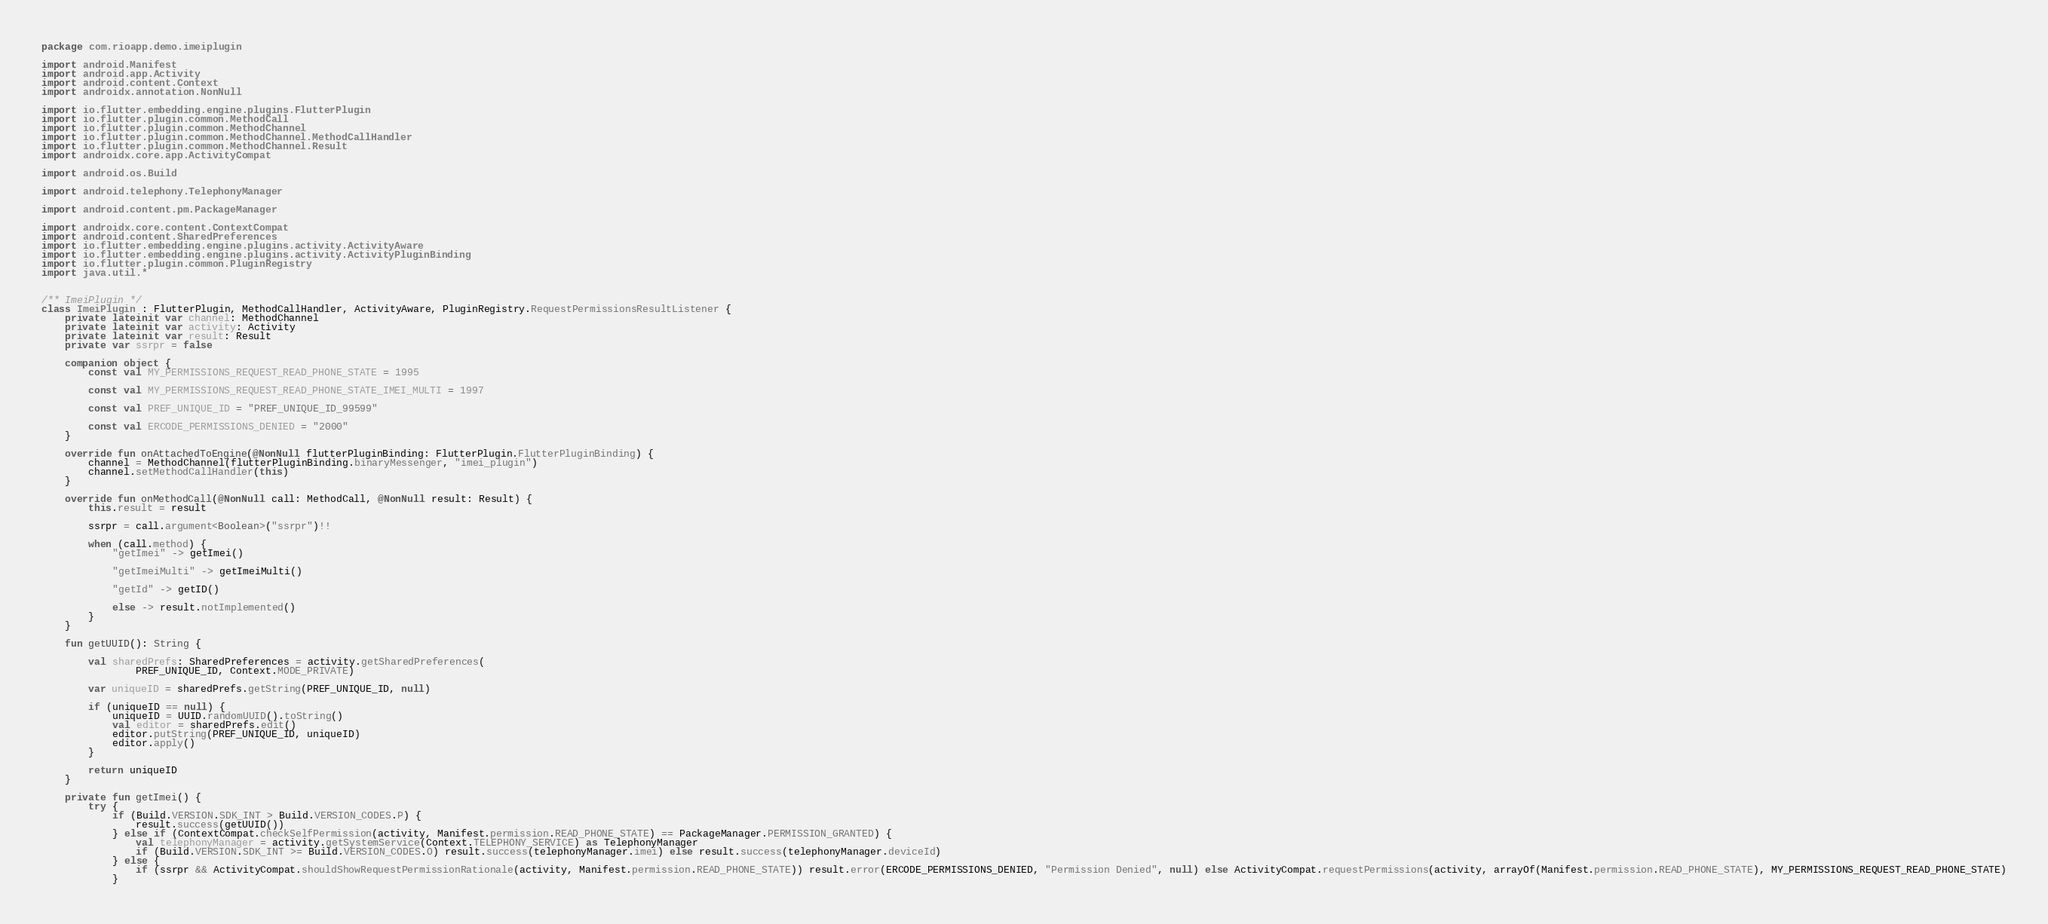Convert code to text. <code><loc_0><loc_0><loc_500><loc_500><_Kotlin_>package com.rioapp.demo.imeiplugin

import android.Manifest
import android.app.Activity
import android.content.Context
import androidx.annotation.NonNull

import io.flutter.embedding.engine.plugins.FlutterPlugin
import io.flutter.plugin.common.MethodCall
import io.flutter.plugin.common.MethodChannel
import io.flutter.plugin.common.MethodChannel.MethodCallHandler
import io.flutter.plugin.common.MethodChannel.Result
import androidx.core.app.ActivityCompat

import android.os.Build

import android.telephony.TelephonyManager

import android.content.pm.PackageManager

import androidx.core.content.ContextCompat
import android.content.SharedPreferences
import io.flutter.embedding.engine.plugins.activity.ActivityAware
import io.flutter.embedding.engine.plugins.activity.ActivityPluginBinding
import io.flutter.plugin.common.PluginRegistry
import java.util.*


/** ImeiPlugin */
class ImeiPlugin : FlutterPlugin, MethodCallHandler, ActivityAware, PluginRegistry.RequestPermissionsResultListener {
    private lateinit var channel: MethodChannel
    private lateinit var activity: Activity
    private lateinit var result: Result
    private var ssrpr = false

    companion object {
        const val MY_PERMISSIONS_REQUEST_READ_PHONE_STATE = 1995

        const val MY_PERMISSIONS_REQUEST_READ_PHONE_STATE_IMEI_MULTI = 1997

        const val PREF_UNIQUE_ID = "PREF_UNIQUE_ID_99599"

        const val ERCODE_PERMISSIONS_DENIED = "2000"
    }

    override fun onAttachedToEngine(@NonNull flutterPluginBinding: FlutterPlugin.FlutterPluginBinding) {
        channel = MethodChannel(flutterPluginBinding.binaryMessenger, "imei_plugin")
        channel.setMethodCallHandler(this)
    }

    override fun onMethodCall(@NonNull call: MethodCall, @NonNull result: Result) {
        this.result = result

        ssrpr = call.argument<Boolean>("ssrpr")!!

        when (call.method) {
            "getImei" -> getImei()

            "getImeiMulti" -> getImeiMulti()

            "getId" -> getID()

            else -> result.notImplemented()
        }
    }

    fun getUUID(): String {

        val sharedPrefs: SharedPreferences = activity.getSharedPreferences(
                PREF_UNIQUE_ID, Context.MODE_PRIVATE)

        var uniqueID = sharedPrefs.getString(PREF_UNIQUE_ID, null)

        if (uniqueID == null) {
            uniqueID = UUID.randomUUID().toString()
            val editor = sharedPrefs.edit()
            editor.putString(PREF_UNIQUE_ID, uniqueID)
            editor.apply()
        }

        return uniqueID
    }

    private fun getImei() {
        try {
            if (Build.VERSION.SDK_INT > Build.VERSION_CODES.P) {
                result.success(getUUID())
            } else if (ContextCompat.checkSelfPermission(activity, Manifest.permission.READ_PHONE_STATE) == PackageManager.PERMISSION_GRANTED) {
                val telephonyManager = activity.getSystemService(Context.TELEPHONY_SERVICE) as TelephonyManager
                if (Build.VERSION.SDK_INT >= Build.VERSION_CODES.O) result.success(telephonyManager.imei) else result.success(telephonyManager.deviceId)
            } else {
                if (ssrpr && ActivityCompat.shouldShowRequestPermissionRationale(activity, Manifest.permission.READ_PHONE_STATE)) result.error(ERCODE_PERMISSIONS_DENIED, "Permission Denied", null) else ActivityCompat.requestPermissions(activity, arrayOf(Manifest.permission.READ_PHONE_STATE), MY_PERMISSIONS_REQUEST_READ_PHONE_STATE)
            }</code> 